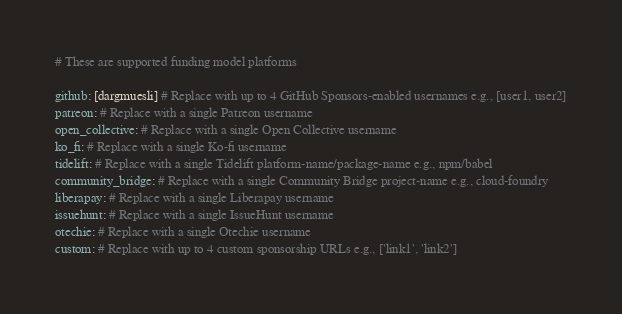<code> <loc_0><loc_0><loc_500><loc_500><_YAML_># These are supported funding model platforms

github: [dargmuesli] # Replace with up to 4 GitHub Sponsors-enabled usernames e.g., [user1, user2]
patreon: # Replace with a single Patreon username
open_collective: # Replace with a single Open Collective username
ko_fi: # Replace with a single Ko-fi username
tidelift: # Replace with a single Tidelift platform-name/package-name e.g., npm/babel
community_bridge: # Replace with a single Community Bridge project-name e.g., cloud-foundry
liberapay: # Replace with a single Liberapay username
issuehunt: # Replace with a single IssueHunt username
otechie: # Replace with a single Otechie username
custom: # Replace with up to 4 custom sponsorship URLs e.g., ['link1', 'link2']
</code> 